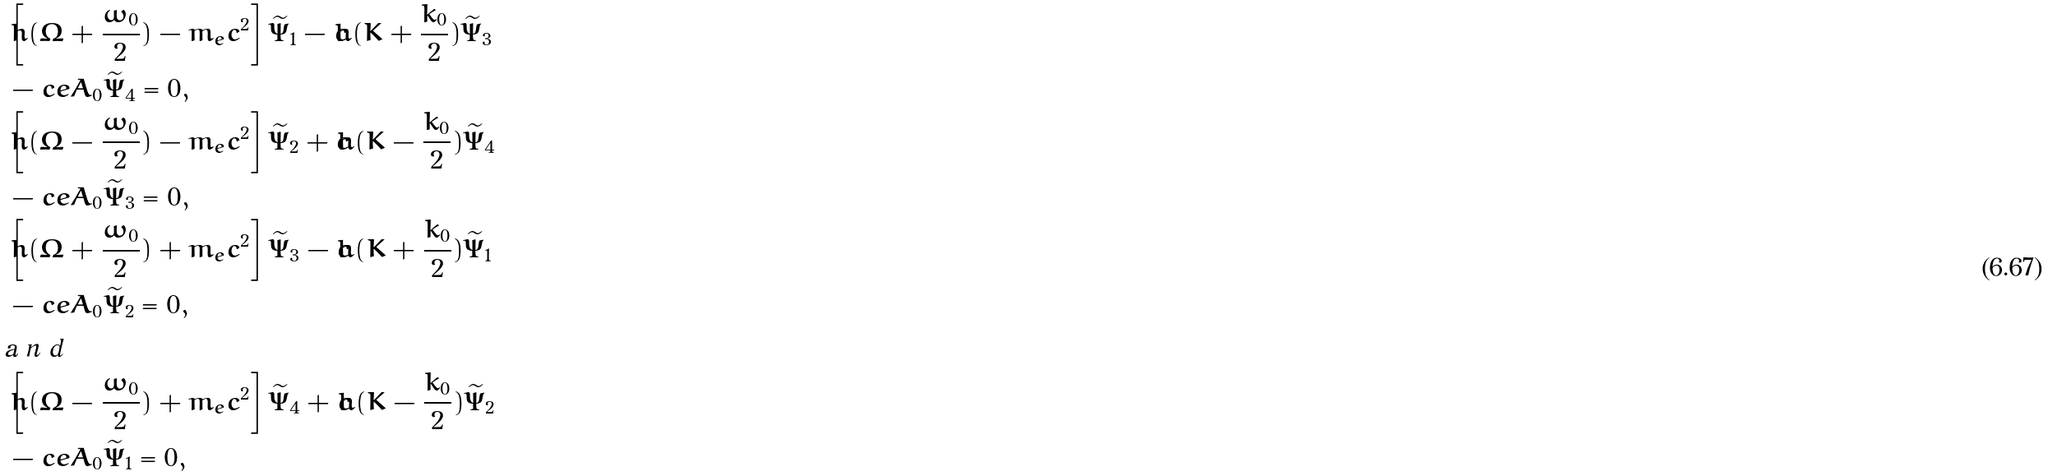<formula> <loc_0><loc_0><loc_500><loc_500>& \left [ \hbar { ( } \Omega + \frac { \omega _ { 0 } } { 2 } ) - m _ { e } c ^ { 2 } \right ] \widetilde { \Psi } _ { 1 } - c \hbar { ( } K + \frac { k _ { 0 } } { 2 } ) \widetilde { \Psi } _ { 3 } \\ & - c e A _ { 0 } \widetilde { \Psi } _ { 4 } = 0 , \\ & \left [ \hbar { ( } \Omega - \frac { \omega _ { 0 } } { 2 } ) - m _ { e } c ^ { 2 } \right ] \widetilde { \Psi } _ { 2 } + c \hbar { ( } K - \frac { k _ { 0 } } { 2 } ) \widetilde { \Psi } _ { 4 } \\ & - c e A _ { 0 } \widetilde { \Psi } _ { 3 } = 0 , \\ & \left [ \hbar { ( } \Omega + \frac { \omega _ { 0 } } { 2 } ) + m _ { e } c ^ { 2 } \right ] \widetilde { \Psi } _ { 3 } - c \hbar { ( } K + \frac { k _ { 0 } } { 2 } ) \widetilde { \Psi } _ { 1 } \\ & - c e A _ { 0 } \widetilde { \Psi } _ { 2 } = 0 , \intertext { a n d } & \left [ \hbar { ( } \Omega - \frac { \omega _ { 0 } } { 2 } ) + m _ { e } c ^ { 2 } \right ] \widetilde { \Psi } _ { 4 } + c \hbar { ( } K - \frac { k _ { 0 } } { 2 } ) \widetilde { \Psi } _ { 2 } \\ & - c e A _ { 0 } \widetilde { \Psi } _ { 1 } = 0 ,</formula> 